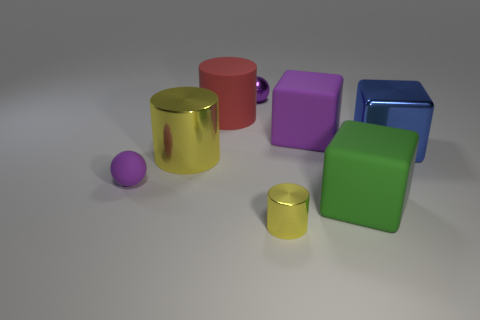Is there a large shiny cylinder of the same color as the tiny cylinder?
Keep it short and to the point. Yes. How many big objects are red cylinders or metal cylinders?
Keep it short and to the point. 2. The big metallic block has what color?
Make the answer very short. Blue. There is a tiny object that is to the left of the object behind the large red thing; what is its shape?
Make the answer very short. Sphere. Is there a tiny thing made of the same material as the large purple object?
Offer a terse response. Yes. There is a metal object behind the blue metallic block; does it have the same size as the red matte object?
Make the answer very short. No. What number of green things are either tiny balls or big rubber blocks?
Provide a short and direct response. 1. What is the material of the yellow cylinder that is left of the red thing?
Your response must be concise. Metal. How many green things are to the left of the metallic cylinder behind the small yellow object?
Offer a terse response. 0. How many other shiny things have the same shape as the big yellow shiny thing?
Offer a terse response. 1. 